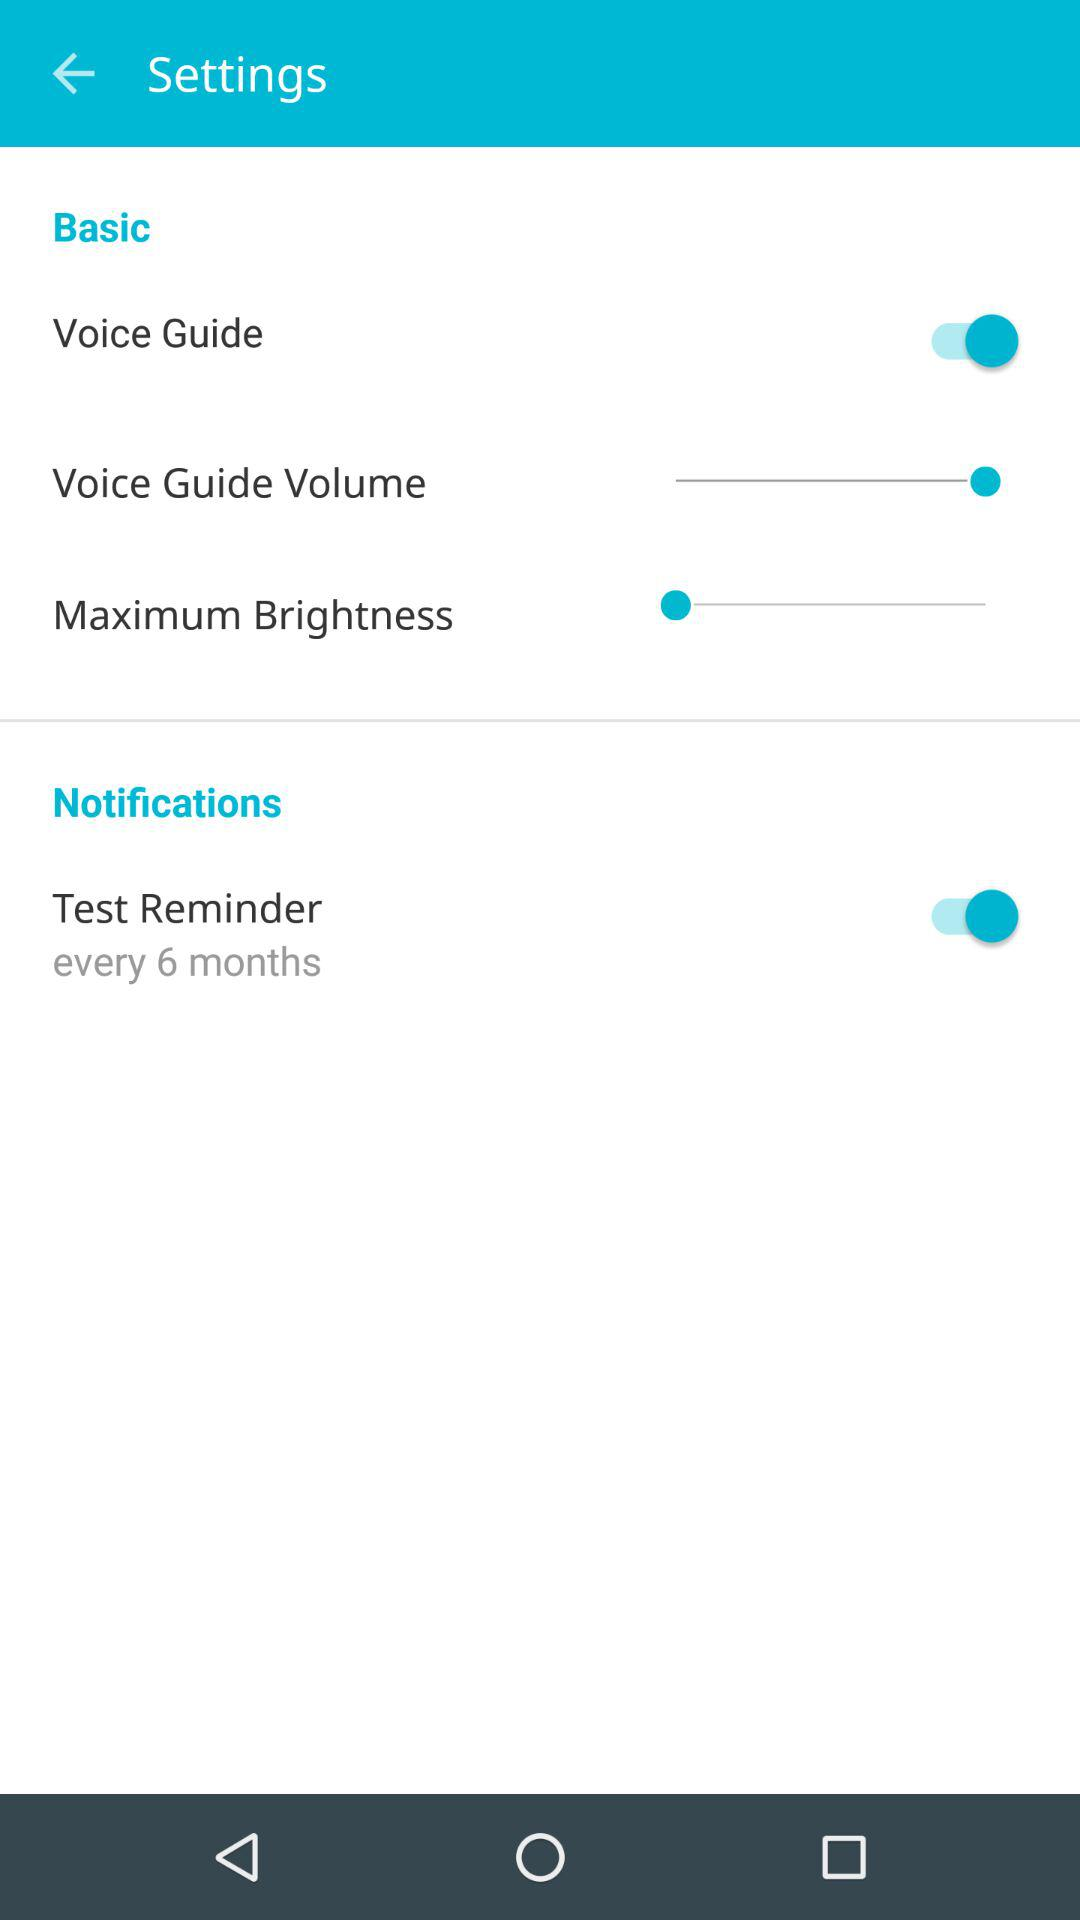How many settings have a switch?
Answer the question using a single word or phrase. 2 